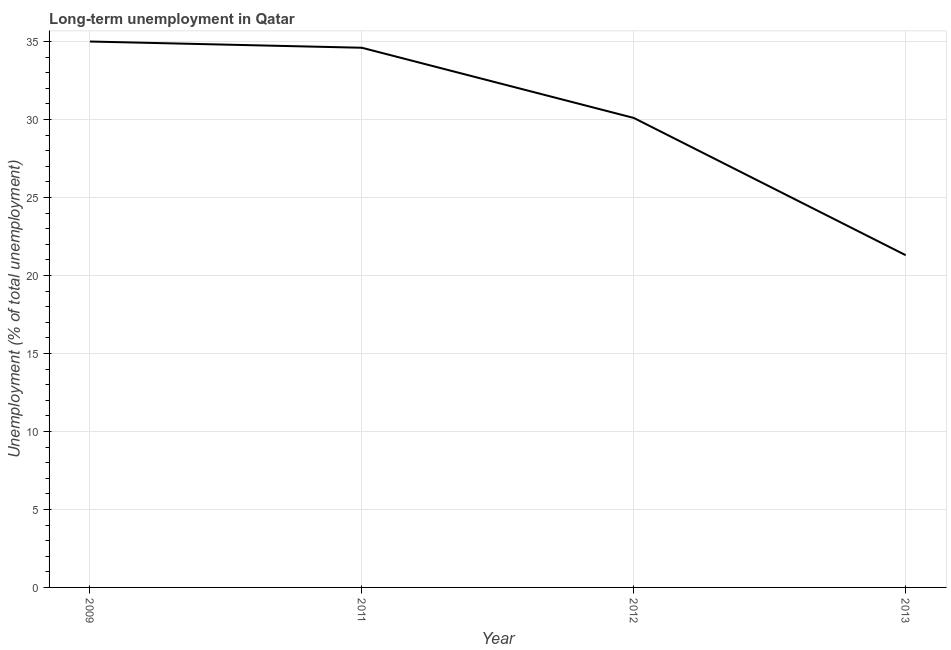What is the long-term unemployment in 2012?
Make the answer very short. 30.1. Across all years, what is the minimum long-term unemployment?
Offer a terse response. 21.3. In which year was the long-term unemployment maximum?
Your response must be concise. 2009. What is the sum of the long-term unemployment?
Provide a succinct answer. 121. What is the difference between the long-term unemployment in 2012 and 2013?
Make the answer very short. 8.8. What is the average long-term unemployment per year?
Provide a short and direct response. 30.25. What is the median long-term unemployment?
Provide a succinct answer. 32.35. What is the ratio of the long-term unemployment in 2009 to that in 2012?
Keep it short and to the point. 1.16. Is the difference between the long-term unemployment in 2009 and 2011 greater than the difference between any two years?
Your answer should be very brief. No. What is the difference between the highest and the second highest long-term unemployment?
Offer a terse response. 0.4. Is the sum of the long-term unemployment in 2009 and 2011 greater than the maximum long-term unemployment across all years?
Offer a very short reply. Yes. What is the difference between the highest and the lowest long-term unemployment?
Ensure brevity in your answer.  13.7. Does the long-term unemployment monotonically increase over the years?
Offer a very short reply. No. What is the title of the graph?
Your response must be concise. Long-term unemployment in Qatar. What is the label or title of the Y-axis?
Your answer should be compact. Unemployment (% of total unemployment). What is the Unemployment (% of total unemployment) in 2011?
Provide a succinct answer. 34.6. What is the Unemployment (% of total unemployment) in 2012?
Offer a terse response. 30.1. What is the Unemployment (% of total unemployment) in 2013?
Give a very brief answer. 21.3. What is the difference between the Unemployment (% of total unemployment) in 2009 and 2011?
Ensure brevity in your answer.  0.4. What is the difference between the Unemployment (% of total unemployment) in 2009 and 2012?
Your answer should be very brief. 4.9. What is the difference between the Unemployment (% of total unemployment) in 2009 and 2013?
Your answer should be compact. 13.7. What is the ratio of the Unemployment (% of total unemployment) in 2009 to that in 2011?
Your answer should be very brief. 1.01. What is the ratio of the Unemployment (% of total unemployment) in 2009 to that in 2012?
Your answer should be compact. 1.16. What is the ratio of the Unemployment (% of total unemployment) in 2009 to that in 2013?
Provide a succinct answer. 1.64. What is the ratio of the Unemployment (% of total unemployment) in 2011 to that in 2012?
Make the answer very short. 1.15. What is the ratio of the Unemployment (% of total unemployment) in 2011 to that in 2013?
Your answer should be very brief. 1.62. What is the ratio of the Unemployment (% of total unemployment) in 2012 to that in 2013?
Make the answer very short. 1.41. 